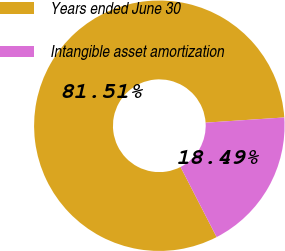Convert chart. <chart><loc_0><loc_0><loc_500><loc_500><pie_chart><fcel>Years ended June 30<fcel>Intangible asset amortization<nl><fcel>81.51%<fcel>18.49%<nl></chart> 